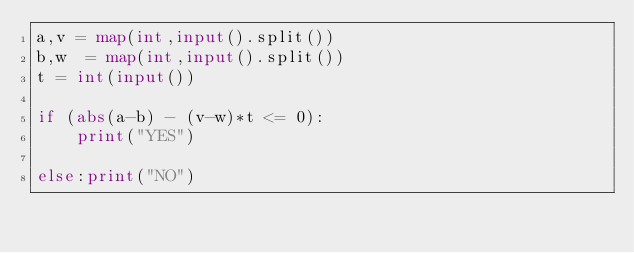<code> <loc_0><loc_0><loc_500><loc_500><_Python_>a,v = map(int,input().split())
b,w  = map(int,input().split())
t = int(input())

if (abs(a-b) - (v-w)*t <= 0):
    print("YES")
    
else:print("NO")</code> 